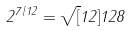Convert formula to latex. <formula><loc_0><loc_0><loc_500><loc_500>2 ^ { 7 / 1 2 } = \sqrt { [ } 1 2 ] { 1 2 8 }</formula> 